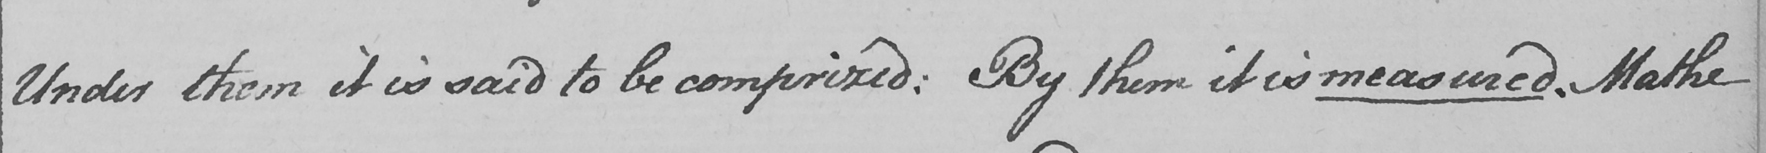Please transcribe the handwritten text in this image. Under them it is said to be comprised :  By them it is measured . Mathe 